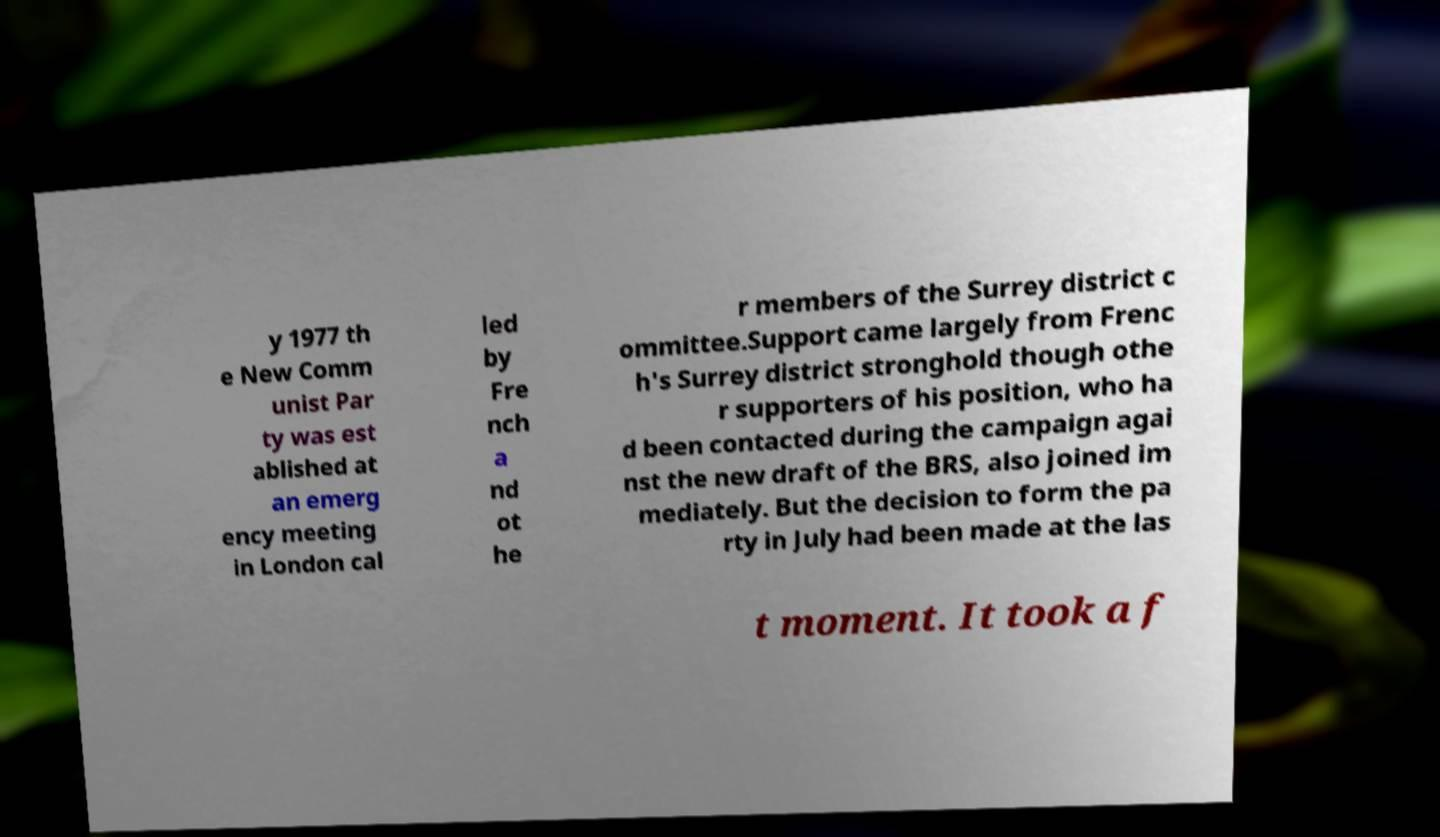Can you accurately transcribe the text from the provided image for me? y 1977 th e New Comm unist Par ty was est ablished at an emerg ency meeting in London cal led by Fre nch a nd ot he r members of the Surrey district c ommittee.Support came largely from Frenc h's Surrey district stronghold though othe r supporters of his position, who ha d been contacted during the campaign agai nst the new draft of the BRS, also joined im mediately. But the decision to form the pa rty in July had been made at the las t moment. It took a f 